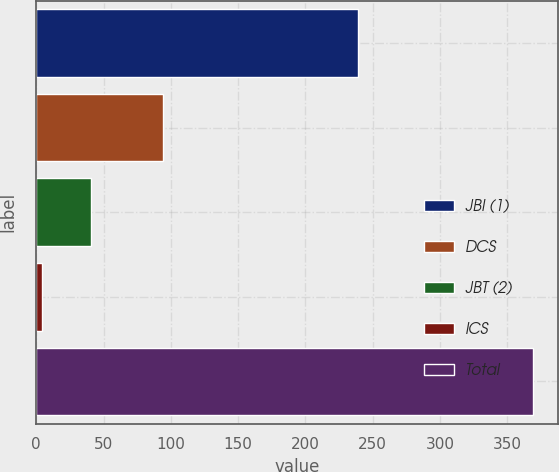Convert chart. <chart><loc_0><loc_0><loc_500><loc_500><bar_chart><fcel>JBI (1)<fcel>DCS<fcel>JBT (2)<fcel>ICS<fcel>Total<nl><fcel>239<fcel>94<fcel>40.5<fcel>4<fcel>369<nl></chart> 